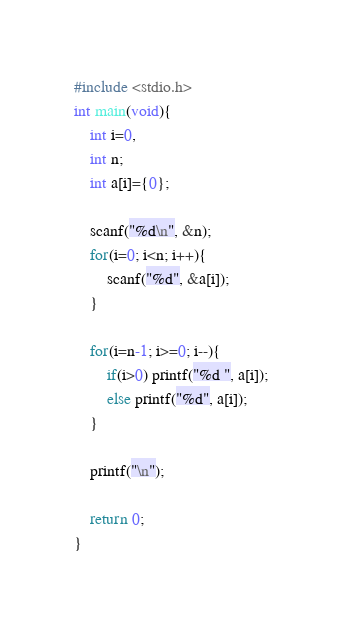<code> <loc_0><loc_0><loc_500><loc_500><_C_>#include <stdio.h>
int main(void){
    int i=0,
    int n;
    int a[i]={0};
    
    scanf("%d\n", &n);
    for(i=0; i<n; i++){
        scanf("%d", &a[i]);
    }
    
    for(i=n-1; i>=0; i--){
        if(i>0) printf("%d ", a[i]);
        else printf("%d", a[i]);
    }
    
    printf("\n");
    
    return 0;
}

</code> 